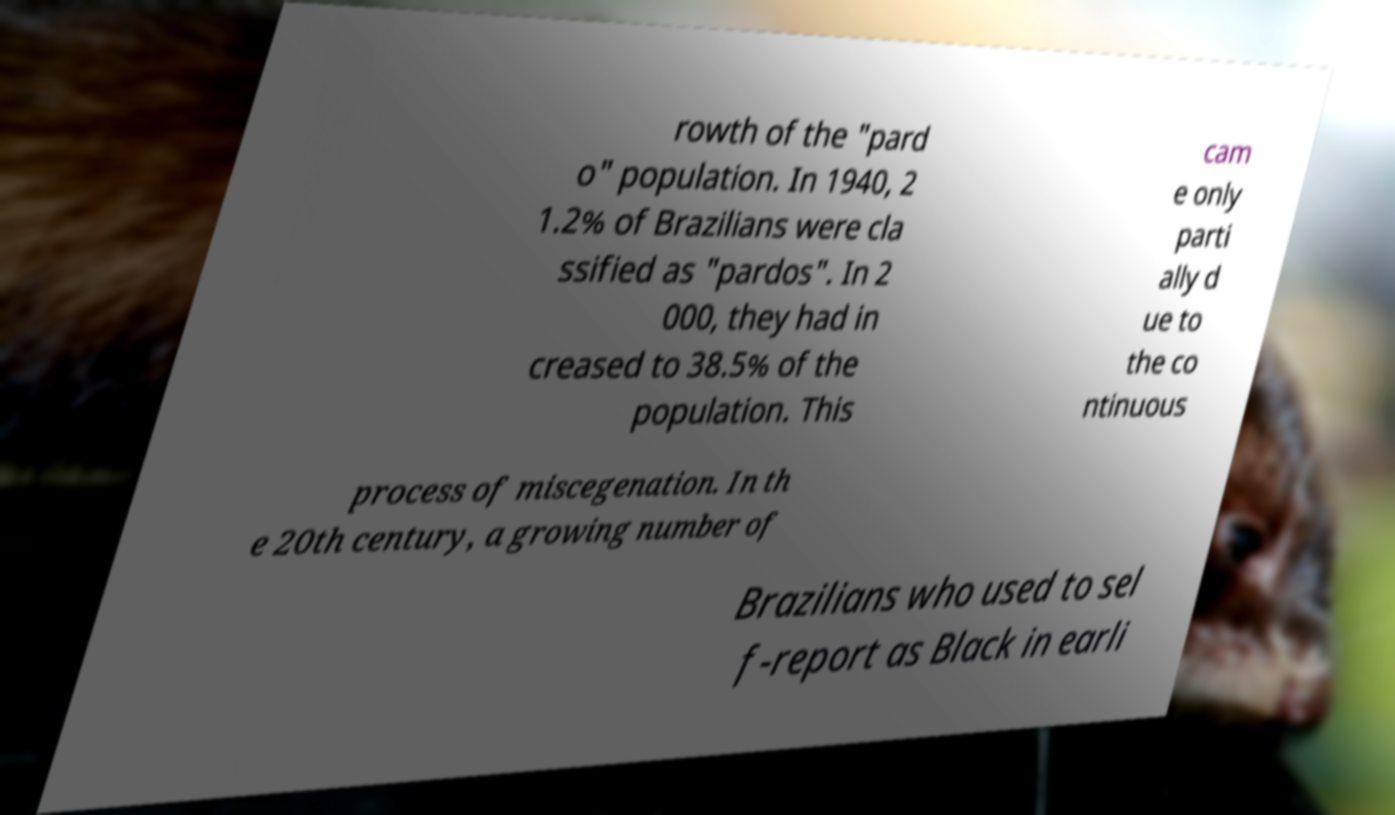Please identify and transcribe the text found in this image. rowth of the "pard o" population. In 1940, 2 1.2% of Brazilians were cla ssified as "pardos". In 2 000, they had in creased to 38.5% of the population. This cam e only parti ally d ue to the co ntinuous process of miscegenation. In th e 20th century, a growing number of Brazilians who used to sel f-report as Black in earli 